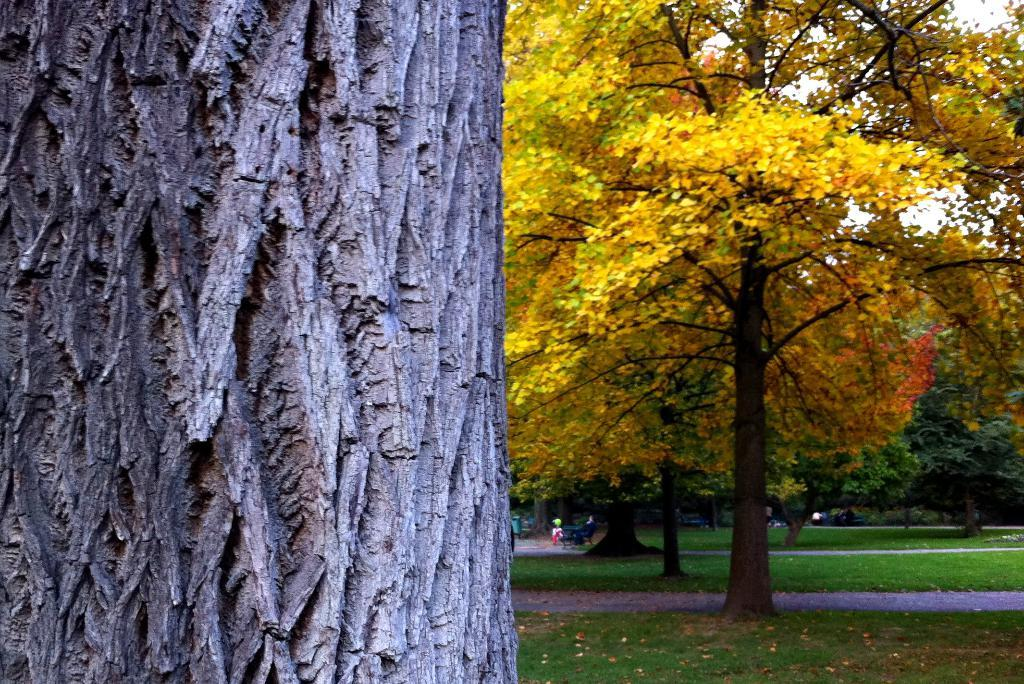What type of vegetation can be seen in the image? There are many trees in the image. What colors are the trees displaying? The trees have yellow, orange, and green colors. What is visible on the ground in the image? There is grass visible on the ground in the image. Can you tell me how many layers are in the cake shown in the image? There is no cake present in the image; it features trees with yellow, orange, and green colors, and grass on the ground. 